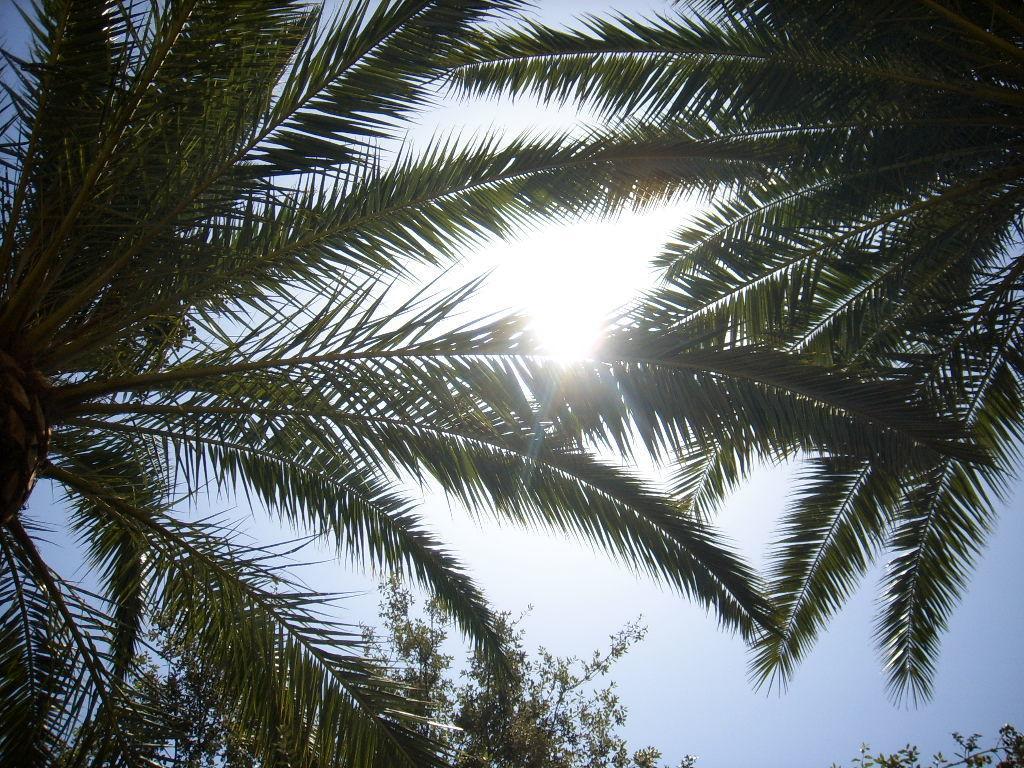Describe this image in one or two sentences. In this picture there are trees in the center of the image. 